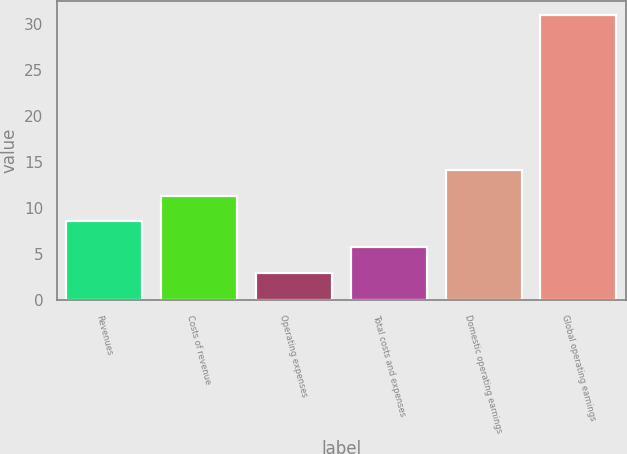Convert chart to OTSL. <chart><loc_0><loc_0><loc_500><loc_500><bar_chart><fcel>Revenues<fcel>Costs of revenue<fcel>Operating expenses<fcel>Total costs and expenses<fcel>Domestic operating earnings<fcel>Global operating earnings<nl><fcel>8.6<fcel>11.4<fcel>3<fcel>5.8<fcel>14.2<fcel>31<nl></chart> 